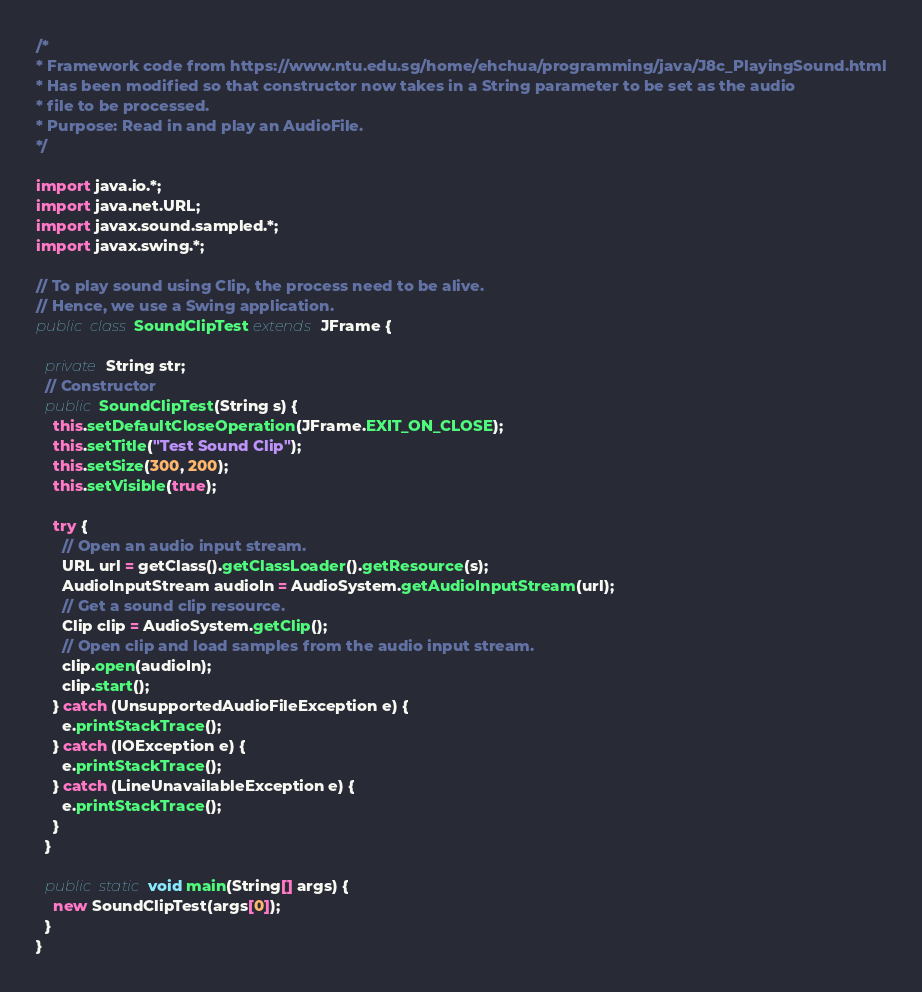Convert code to text. <code><loc_0><loc_0><loc_500><loc_500><_Java_>/*
* Framework code from https://www.ntu.edu.sg/home/ehchua/programming/java/J8c_PlayingSound.html
* Has been modified so that constructor now takes in a String parameter to be set as the audio
* file to be processed.
* Purpose: Read in and play an AudioFile.
*/

import java.io.*;
import java.net.URL;
import javax.sound.sampled.*;
import javax.swing.*;

// To play sound using Clip, the process need to be alive.
// Hence, we use a Swing application.
public class SoundClipTest extends JFrame {

  private String str;
  // Constructor
  public SoundClipTest(String s) {
    this.setDefaultCloseOperation(JFrame.EXIT_ON_CLOSE);
    this.setTitle("Test Sound Clip");
    this.setSize(300, 200);
    this.setVisible(true);

    try {
      // Open an audio input stream.
      URL url = getClass().getClassLoader().getResource(s);
      AudioInputStream audioIn = AudioSystem.getAudioInputStream(url);
      // Get a sound clip resource.
      Clip clip = AudioSystem.getClip();
      // Open clip and load samples from the audio input stream.
      clip.open(audioIn);
      clip.start();
    } catch (UnsupportedAudioFileException e) {
      e.printStackTrace();
    } catch (IOException e) {
      e.printStackTrace();
    } catch (LineUnavailableException e) {
      e.printStackTrace();
    }
  }

  public static void main(String[] args) {
    new SoundClipTest(args[0]);
  }
}
</code> 